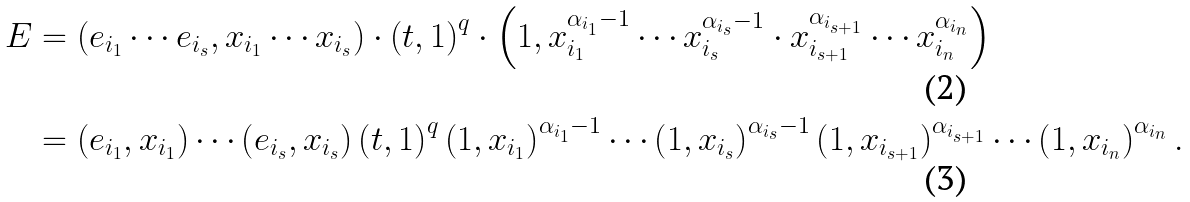Convert formula to latex. <formula><loc_0><loc_0><loc_500><loc_500>E & = \left ( e _ { i _ { 1 } } \cdots e _ { i _ { s } } , x _ { i _ { 1 } } \cdots x _ { i _ { s } } \right ) \cdot \left ( t , 1 \right ) ^ { q } \cdot \left ( 1 , x _ { i _ { 1 } } ^ { \alpha _ { i _ { 1 } } - 1 } \cdots x _ { i _ { s } } ^ { \alpha _ { i _ { s } } - 1 } \cdot x _ { i _ { s + 1 } } ^ { \alpha _ { i _ { s + 1 } } } \cdots x _ { i _ { n } } ^ { \alpha _ { i _ { n } } } \right ) \\ & = \left ( e _ { i _ { 1 } } , x _ { i _ { 1 } } \right ) \cdots \left ( e _ { i _ { s } } , x _ { i _ { s } } \right ) \left ( t , 1 \right ) ^ { q } \left ( 1 , x _ { i _ { 1 } } \right ) ^ { \alpha _ { i _ { 1 } } - 1 } \cdots \left ( 1 , x _ { i _ { s } } \right ) ^ { \alpha _ { i _ { s } } - 1 } \left ( 1 , x _ { i _ { s + 1 } } \right ) ^ { \alpha _ { i _ { s + 1 } } } \cdots \left ( 1 , x _ { i _ { n } } \right ) ^ { \alpha _ { i _ { n } } } .</formula> 